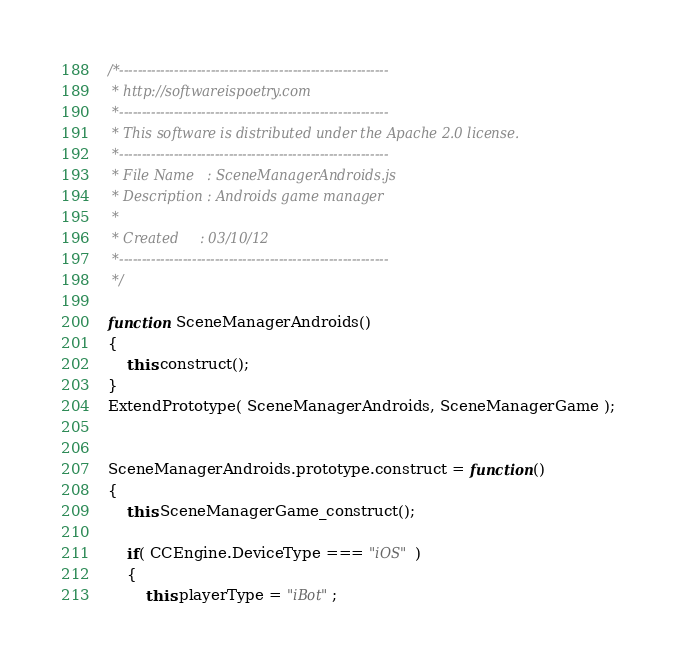<code> <loc_0><loc_0><loc_500><loc_500><_JavaScript_>/*-----------------------------------------------------------
 * http://softwareispoetry.com
 *-----------------------------------------------------------
 * This software is distributed under the Apache 2.0 license.
 *-----------------------------------------------------------
 * File Name   : SceneManagerAndroids.js
 * Description : Androids game manager
 *
 * Created     : 03/10/12
 *-----------------------------------------------------------
 */

function SceneManagerAndroids()
{
    this.construct();
}
ExtendPrototype( SceneManagerAndroids, SceneManagerGame );


SceneManagerAndroids.prototype.construct = function()
{
    this.SceneManagerGame_construct();

    if( CCEngine.DeviceType === "iOS" )
    {
        this.playerType = "iBot";</code> 